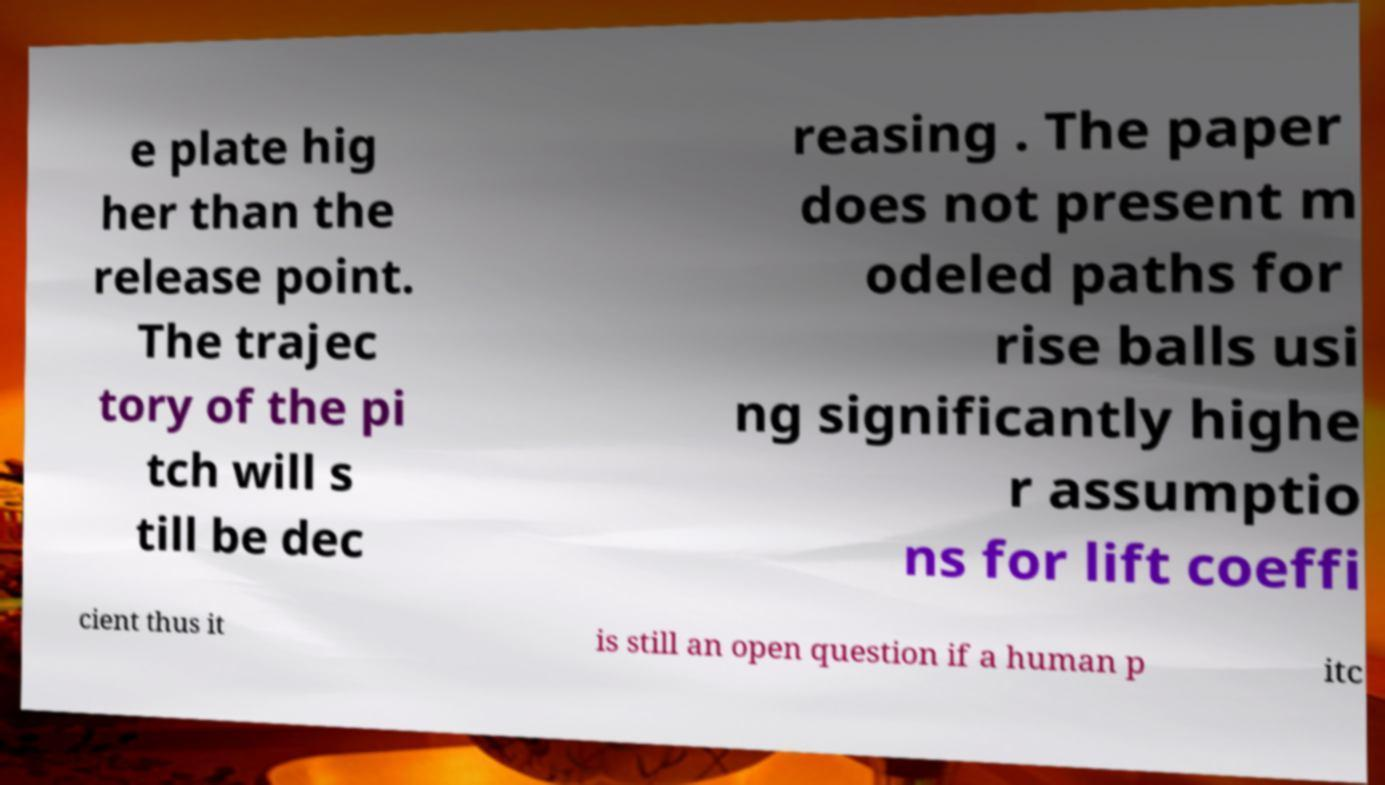Could you assist in decoding the text presented in this image and type it out clearly? e plate hig her than the release point. The trajec tory of the pi tch will s till be dec reasing . The paper does not present m odeled paths for rise balls usi ng significantly highe r assumptio ns for lift coeffi cient thus it is still an open question if a human p itc 